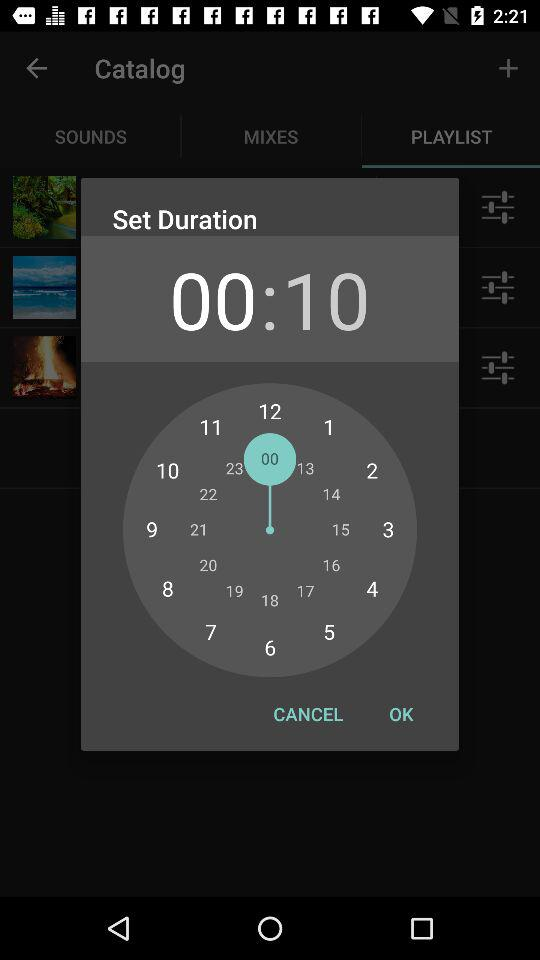What is the set time duration? The set time duration is 10 seconds. 